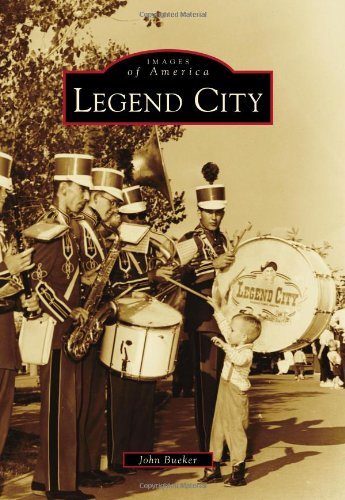Is this book related to History? Absolutely, this book plays a crucial role in detailing the historical significance of Legend City, capturing the nuances of its existence and how it has shaped its community over the years. 